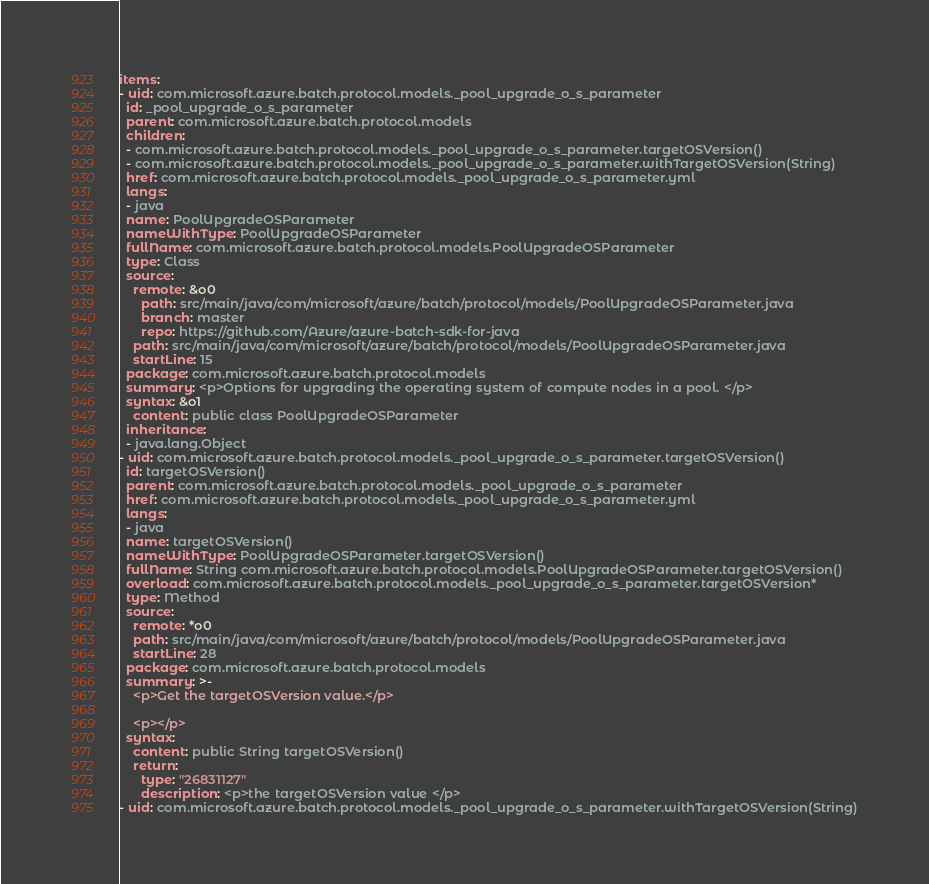<code> <loc_0><loc_0><loc_500><loc_500><_YAML_>items:
- uid: com.microsoft.azure.batch.protocol.models._pool_upgrade_o_s_parameter
  id: _pool_upgrade_o_s_parameter
  parent: com.microsoft.azure.batch.protocol.models
  children:
  - com.microsoft.azure.batch.protocol.models._pool_upgrade_o_s_parameter.targetOSVersion()
  - com.microsoft.azure.batch.protocol.models._pool_upgrade_o_s_parameter.withTargetOSVersion(String)
  href: com.microsoft.azure.batch.protocol.models._pool_upgrade_o_s_parameter.yml
  langs:
  - java
  name: PoolUpgradeOSParameter
  nameWithType: PoolUpgradeOSParameter
  fullName: com.microsoft.azure.batch.protocol.models.PoolUpgradeOSParameter
  type: Class
  source:
    remote: &o0
      path: src/main/java/com/microsoft/azure/batch/protocol/models/PoolUpgradeOSParameter.java
      branch: master
      repo: https://github.com/Azure/azure-batch-sdk-for-java
    path: src/main/java/com/microsoft/azure/batch/protocol/models/PoolUpgradeOSParameter.java
    startLine: 15
  package: com.microsoft.azure.batch.protocol.models
  summary: <p>Options for upgrading the operating system of compute nodes in a pool. </p>
  syntax: &o1
    content: public class PoolUpgradeOSParameter
  inheritance:
  - java.lang.Object
- uid: com.microsoft.azure.batch.protocol.models._pool_upgrade_o_s_parameter.targetOSVersion()
  id: targetOSVersion()
  parent: com.microsoft.azure.batch.protocol.models._pool_upgrade_o_s_parameter
  href: com.microsoft.azure.batch.protocol.models._pool_upgrade_o_s_parameter.yml
  langs:
  - java
  name: targetOSVersion()
  nameWithType: PoolUpgradeOSParameter.targetOSVersion()
  fullName: String com.microsoft.azure.batch.protocol.models.PoolUpgradeOSParameter.targetOSVersion()
  overload: com.microsoft.azure.batch.protocol.models._pool_upgrade_o_s_parameter.targetOSVersion*
  type: Method
  source:
    remote: *o0
    path: src/main/java/com/microsoft/azure/batch/protocol/models/PoolUpgradeOSParameter.java
    startLine: 28
  package: com.microsoft.azure.batch.protocol.models
  summary: >-
    <p>Get the targetOSVersion value.</p>

    <p></p>
  syntax:
    content: public String targetOSVersion()
    return:
      type: "26831127"
      description: <p>the targetOSVersion value </p>
- uid: com.microsoft.azure.batch.protocol.models._pool_upgrade_o_s_parameter.withTargetOSVersion(String)</code> 